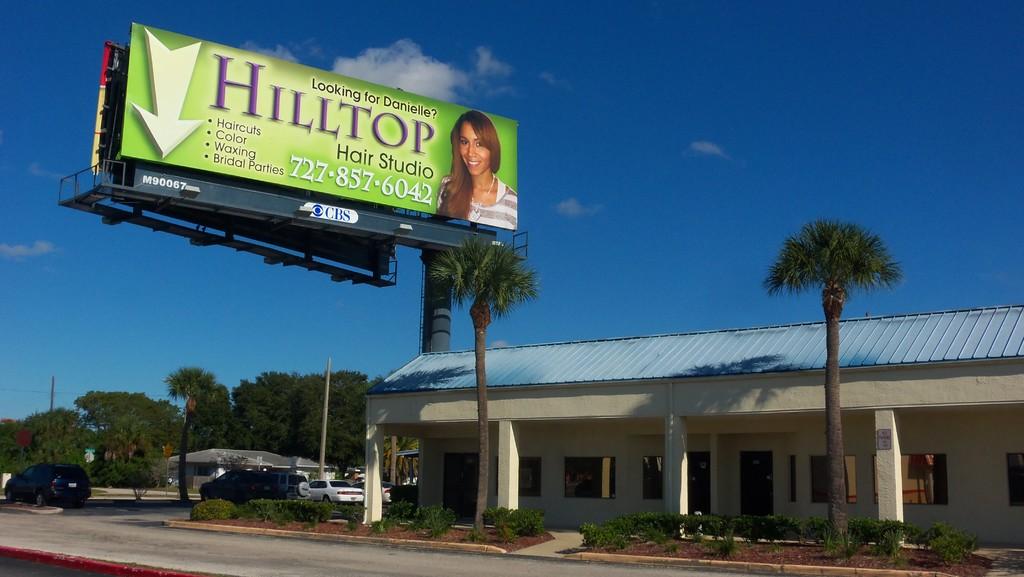What is the name of the hair studio?
Keep it short and to the point. Hilltop. 